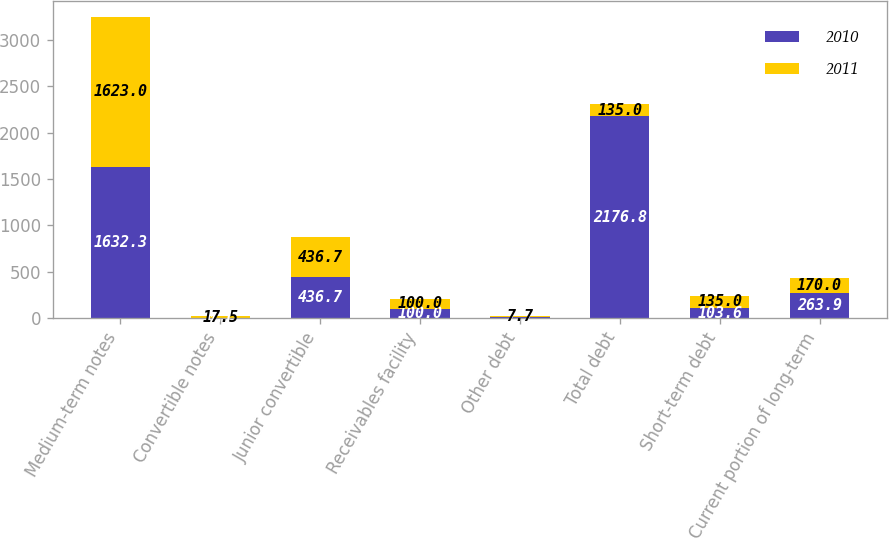Convert chart to OTSL. <chart><loc_0><loc_0><loc_500><loc_500><stacked_bar_chart><ecel><fcel>Medium-term notes<fcel>Convertible notes<fcel>Junior convertible<fcel>Receivables facility<fcel>Other debt<fcel>Total debt<fcel>Short-term debt<fcel>Current portion of long-term<nl><fcel>2010<fcel>1632.3<fcel>0.1<fcel>436.7<fcel>100<fcel>7.7<fcel>2176.8<fcel>103.6<fcel>263.9<nl><fcel>2011<fcel>1623<fcel>17.5<fcel>436.7<fcel>100<fcel>7.7<fcel>135<fcel>135<fcel>170<nl></chart> 